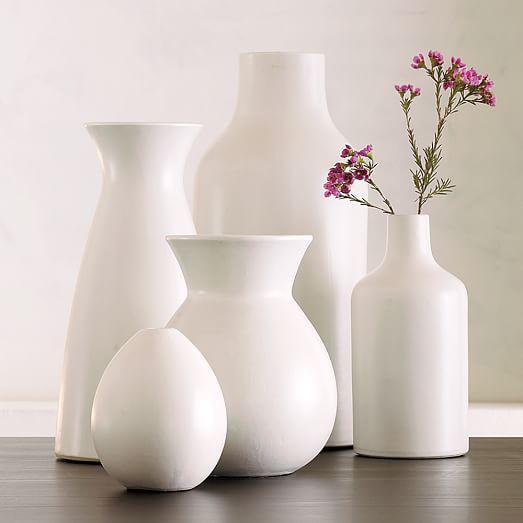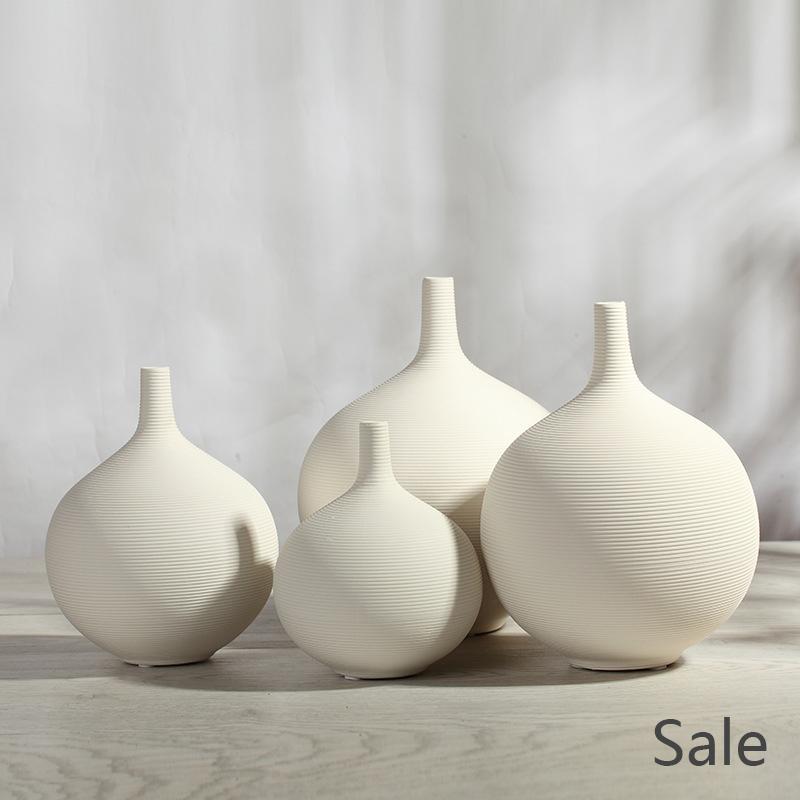The first image is the image on the left, the second image is the image on the right. For the images shown, is this caption "There is no more than three sculptures in the left image." true? Answer yes or no. No. The first image is the image on the left, the second image is the image on the right. Analyze the images presented: Is the assertion "There are at most six vases." valid? Answer yes or no. No. 